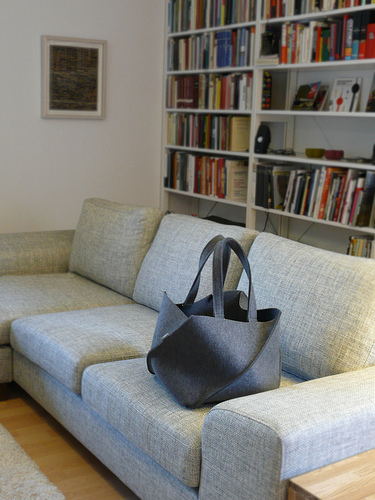<image>
Is there a bag behind the couch? No. The bag is not behind the couch. From this viewpoint, the bag appears to be positioned elsewhere in the scene. Where is the bag in relation to the sofa? Is it above the sofa? No. The bag is not positioned above the sofa. The vertical arrangement shows a different relationship. 